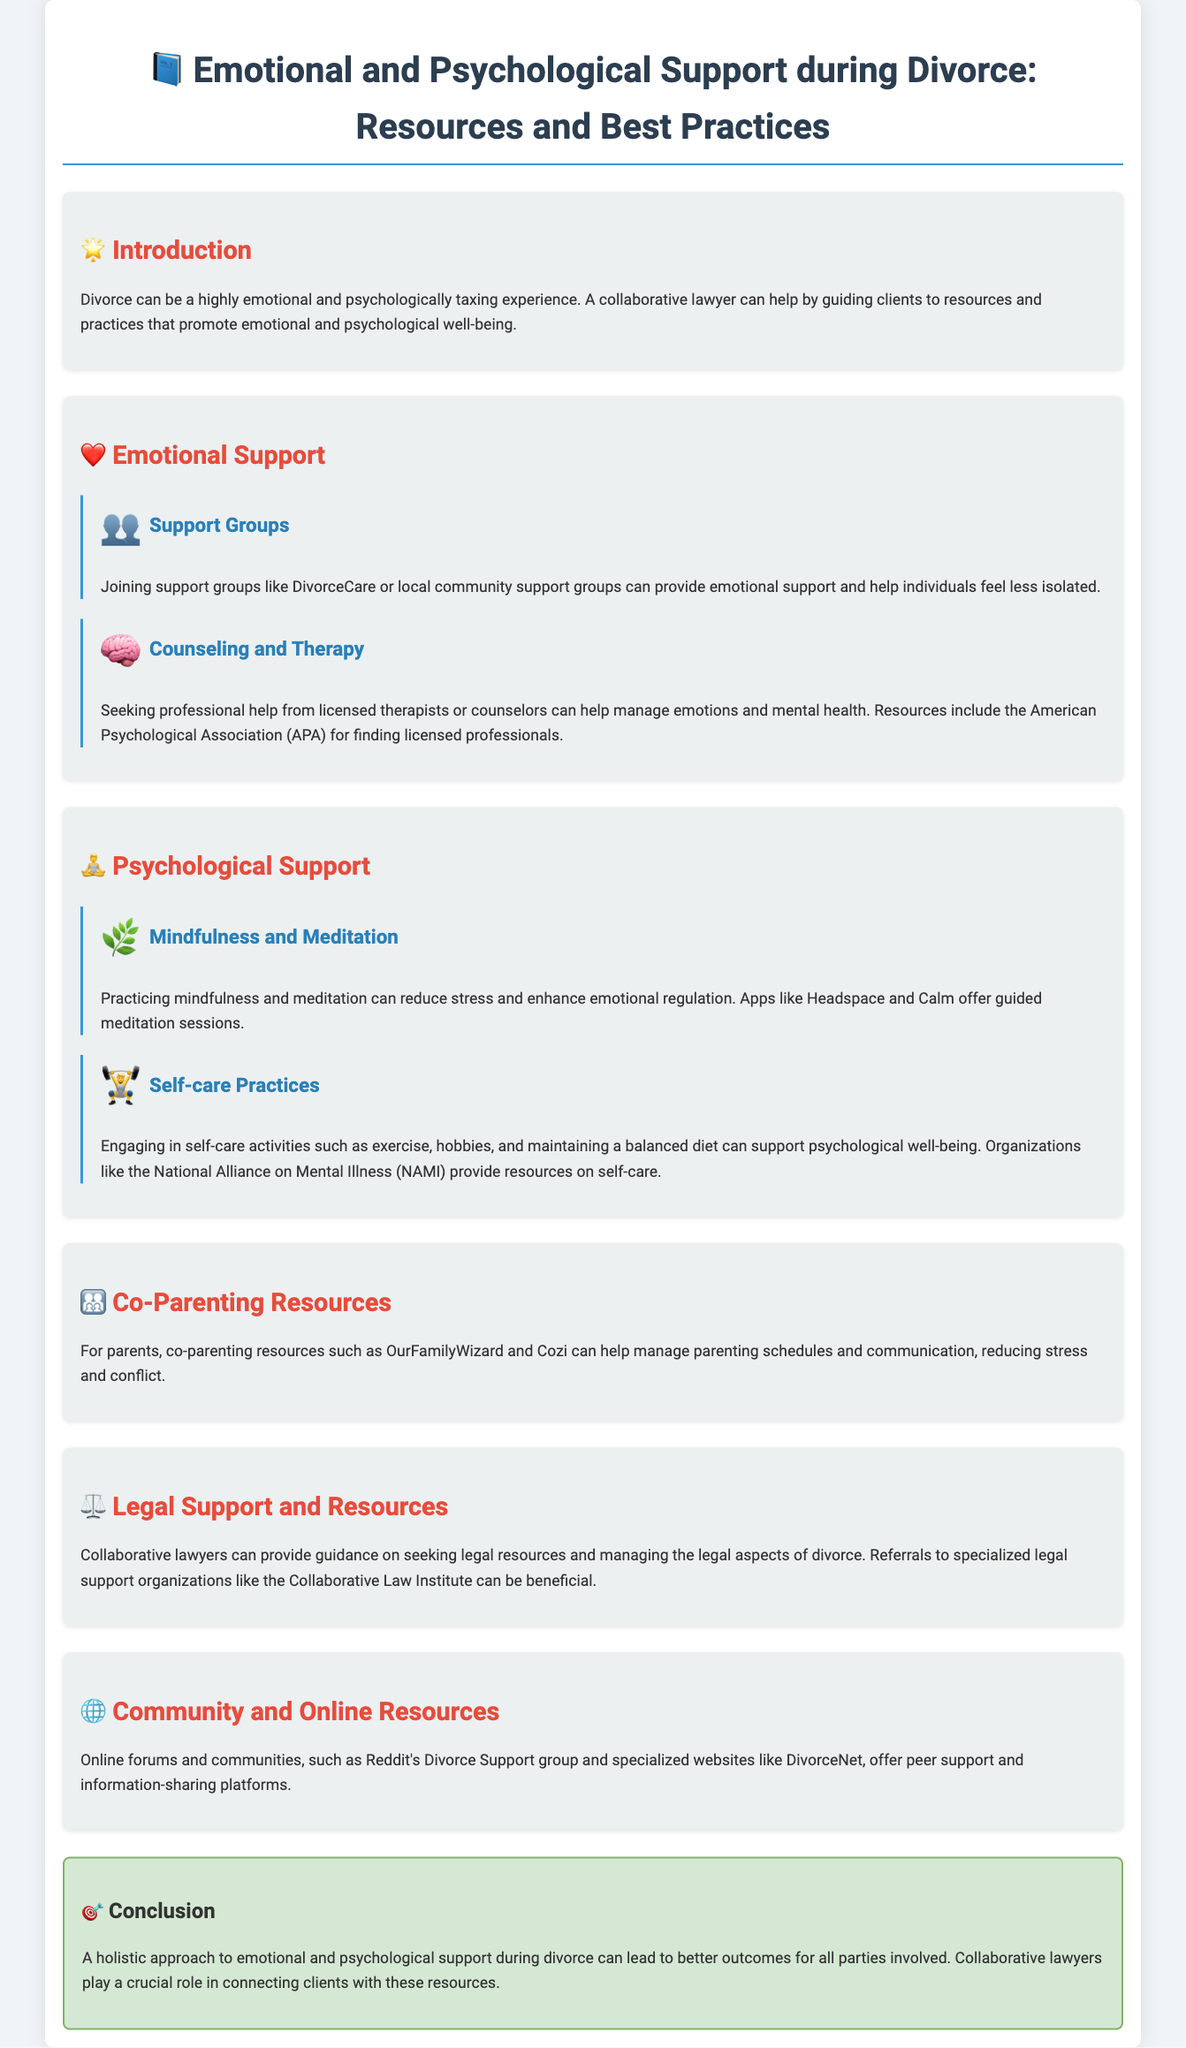What is the title of the document? The title is presented prominently at the beginning of the document as an introduction to its content.
Answer: Emotional and Psychological Support during Divorce: Resources and Best Practices What is one resource for counseling and therapy? The document lists professional help as a crucial resource and mentions the American Psychological Association specifically for this purpose.
Answer: American Psychological Association What is a recommended app for mindfulness? The document mentions specific applications that facilitate mindfulness practices, helping with stress reduction.
Answer: Headspace What organization provides resources on self-care? The document indicates specific organizations that offer support and information on self-care practices during divorce.
Answer: National Alliance on Mental Illness What type of groups can provide emotional support? The section details specific types of groups that individuals can join to obtain emotional support during their divorce.
Answer: Support groups What is the conclusion of the document? The conclusion summarizes the document's main theme about the importance of a holistic approach to emotional and psychological support during divorce.
Answer: A holistic approach to emotional and psychological support during divorce Which section addresses co-parenting? The document explicitly includes sections that focus on different aspects of managing parenting responsibilities during and after divorce.
Answer: Co-Parenting Resources What do collaborative lawyers provide guidance on? The document mentions specific legal aspects where collaborative lawyers can assist clients going through divorce.
Answer: Legal resources 